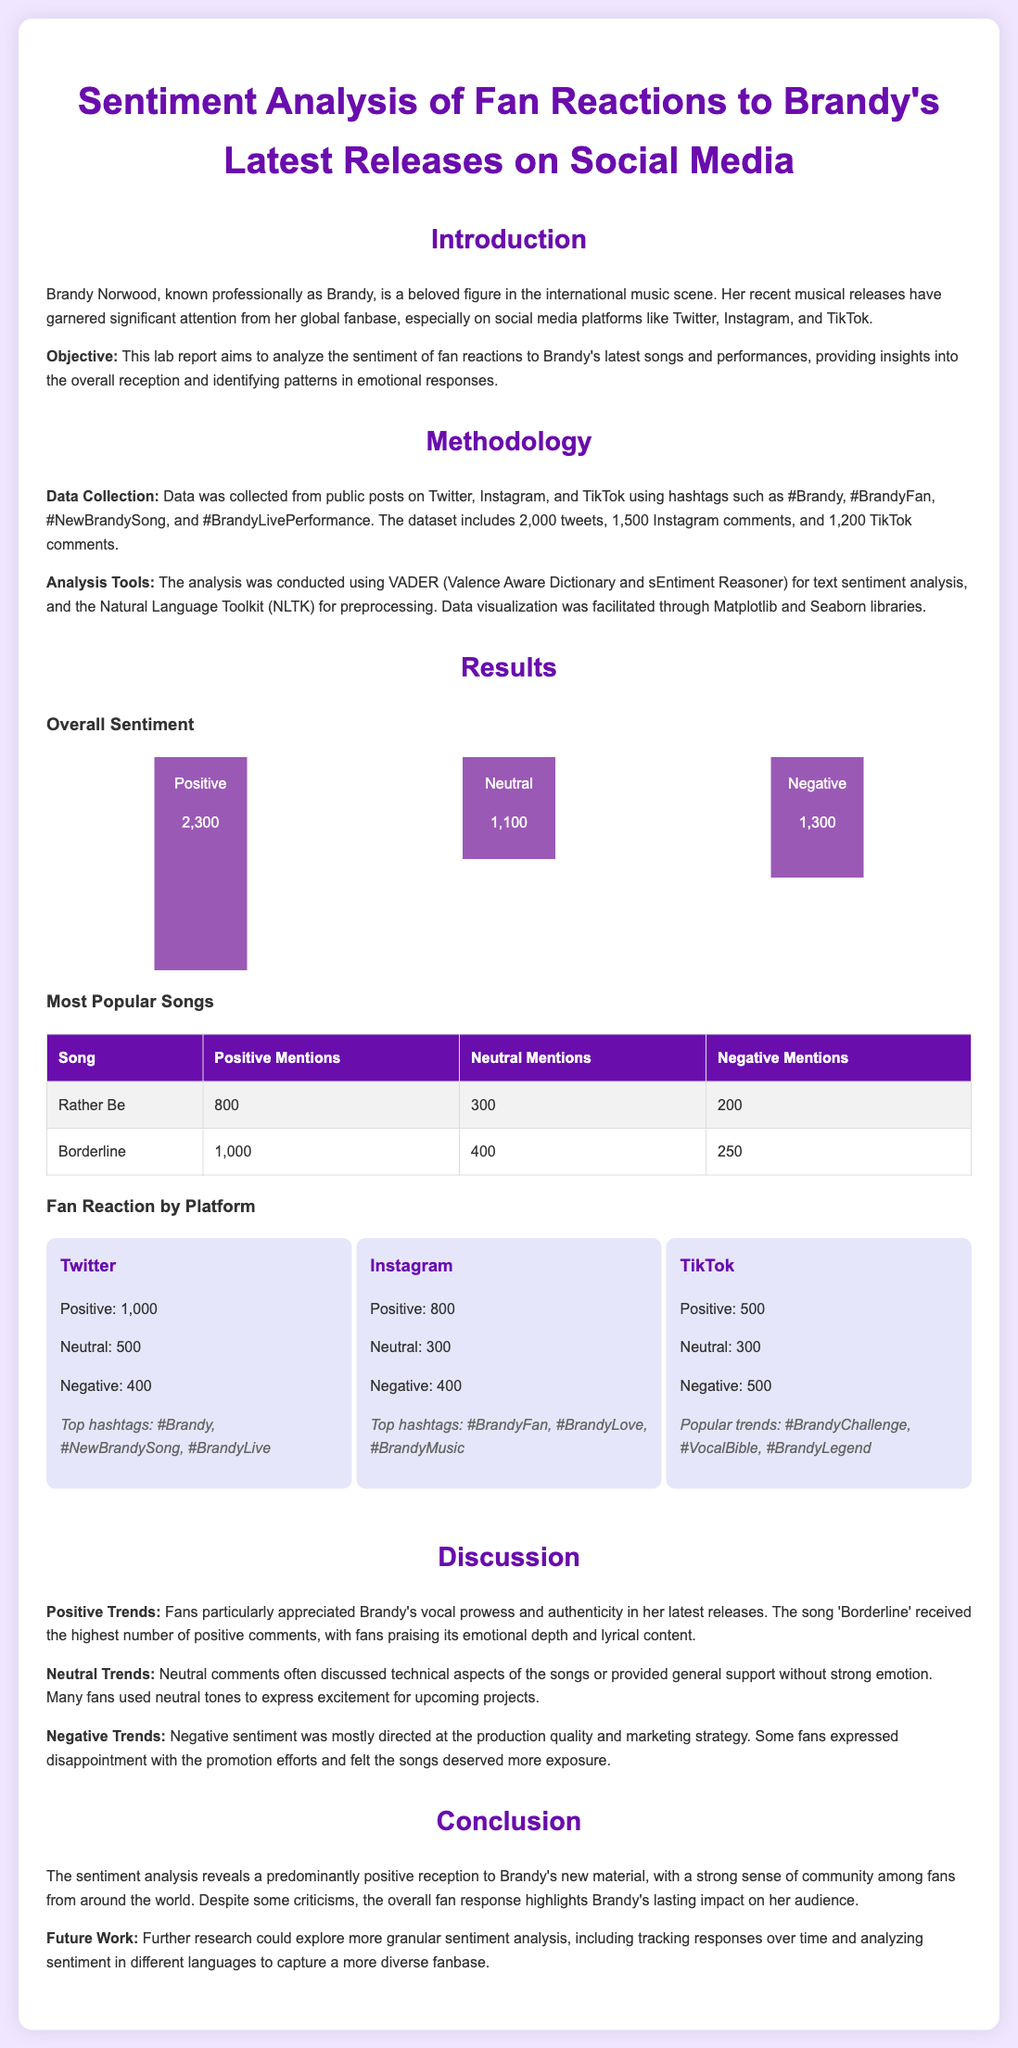what is the total number of positive mentions for the song "Borderline"? The document states that "Borderline" received 1,000 positive mentions.
Answer: 1,000 how many tweets were analyzed in the study? The lab report mentions collecting data from 2,000 tweets.
Answer: 2,000 which social media platform had the lowest number of positive fan reactions? The TikTok platform had the lowest positive reactions, with 500.
Answer: TikTok what issue did fans express disappointment about? Fans expressed disappointment with the production quality and marketing strategy.
Answer: Production quality how many total comments were collected from Instagram? The report states that 1,500 Instagram comments were collected.
Answer: 1,500 which song received the highest number of positive comments? The highest number of positive comments was for the song "Borderline."
Answer: Borderline how many negative mentions were recorded for the song "Rather Be"? "Rather Be" had 200 negative mentions according to the table.
Answer: 200 what are some of the top hashtags used on Twitter according to the report? Top hashtags included #Brandy, #NewBrandySong, #BrandyLive.
Answer: #Brandy, #NewBrandySong, #BrandyLive what was the objective of the lab report? The objective was to analyze the sentiment of fan reactions to Brandy's latest songs and performances.
Answer: Analyze sentiment 